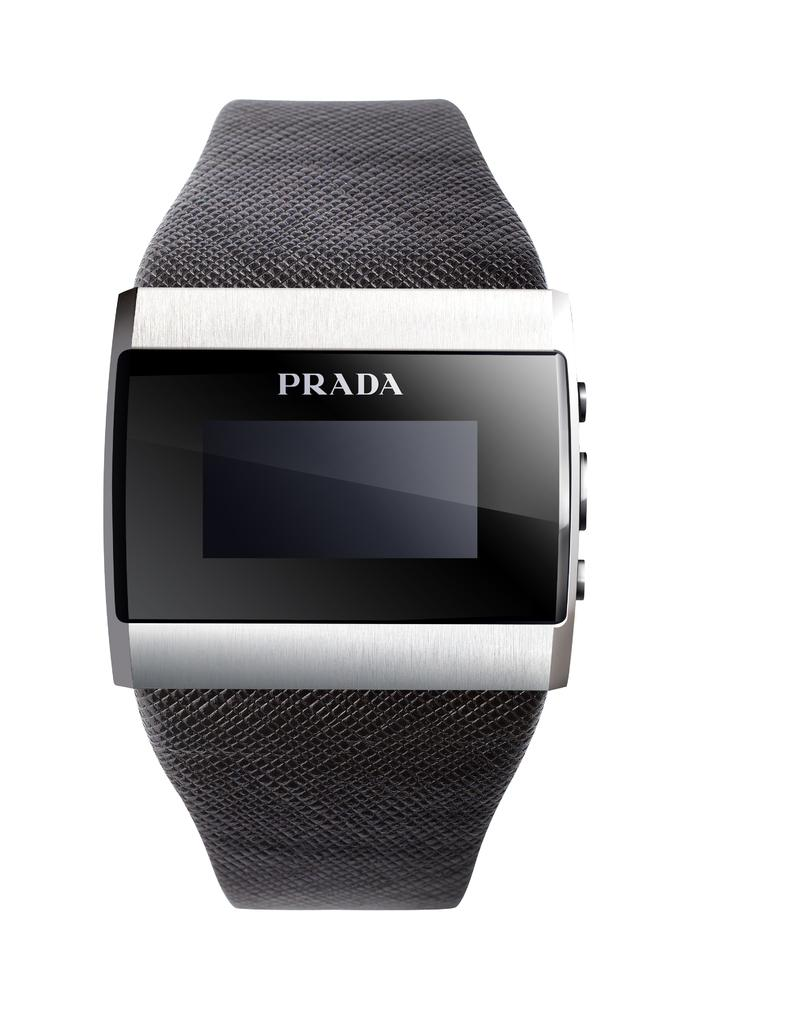What type of watch is visible in the image? There is a digital watch in the image. Where is the digital watch located in the image? The digital watch is in the center of the image. What type of oil is being used to clean the blood off the guide in the image? There is no guide, oil, or blood present in the image; it only features a digital watch in the center. 